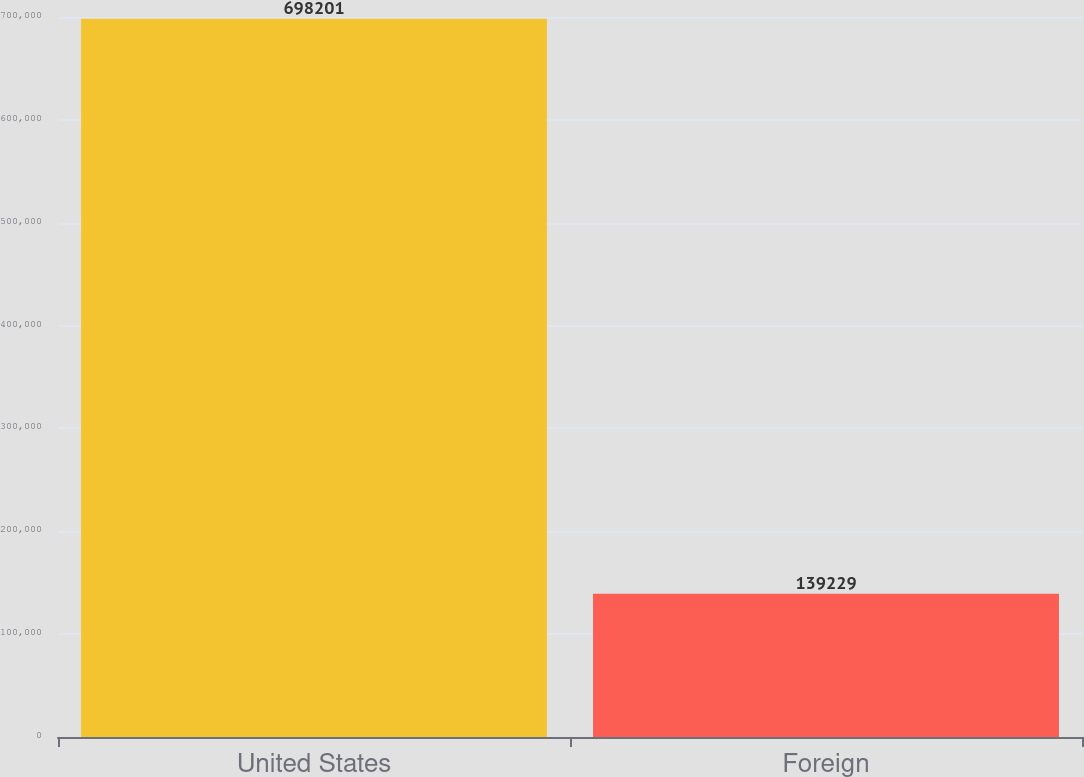Convert chart. <chart><loc_0><loc_0><loc_500><loc_500><bar_chart><fcel>United States<fcel>Foreign<nl><fcel>698201<fcel>139229<nl></chart> 